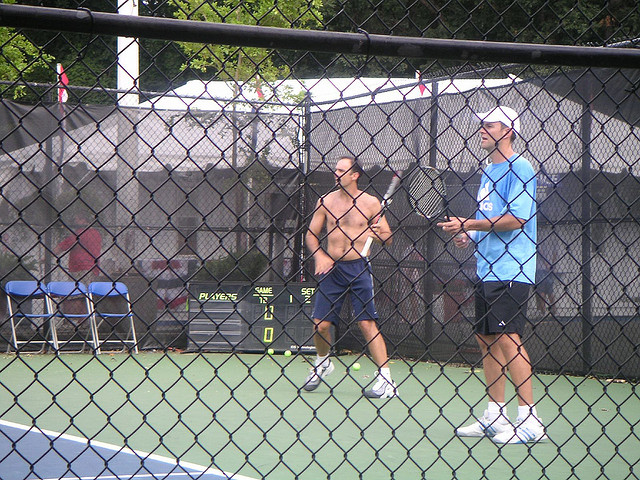What are the men doing in the picture? The men appear to be engaged in a game of paddle tennis, a sport similar to traditional tennis but played on a smaller court and typically with solid paddles instead of strung racquets. What equipment can you identify in the image related to the game they're playing? In addition to the solid paddles they're holding, there's a small, yellow ball consistent with those used in paddle tennis. On the court, we can also see a scoring device indicating 'Players' and 'Sets', which is used to keep track of the game's progression. 